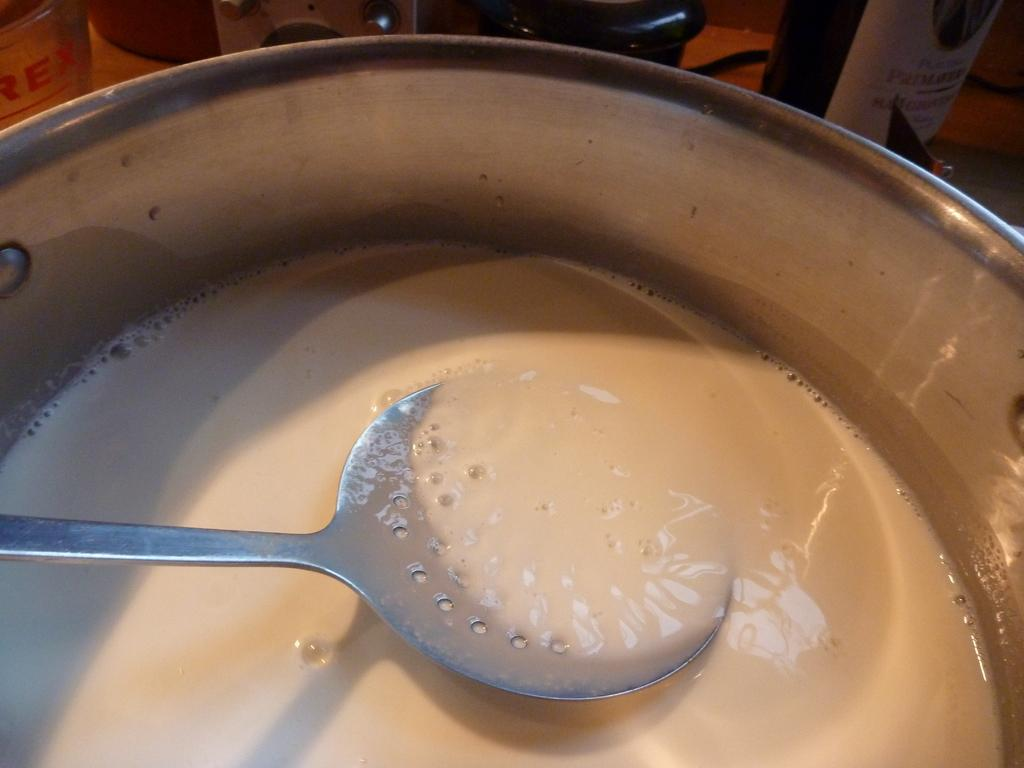What is in the bowl that is visible in the image? The bowl contains milk in the image. What utensil is present in the image? There is a spoon in the image. What can be seen at the top of the image? There are two bottles and other objects visible at the top of the image. What type of learning can be observed in the image? There is no learning activity depicted in the image; it primarily features a bowl of milk and other objects. 